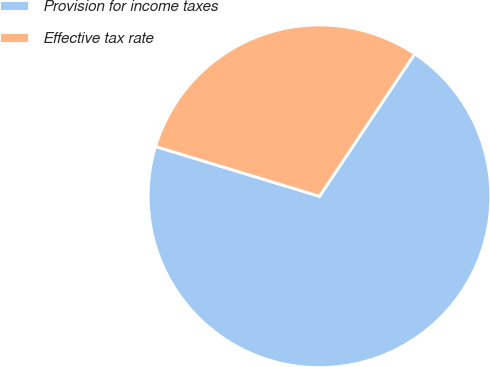<chart> <loc_0><loc_0><loc_500><loc_500><pie_chart><fcel>Provision for income taxes<fcel>Effective tax rate<nl><fcel>70.31%<fcel>29.69%<nl></chart> 